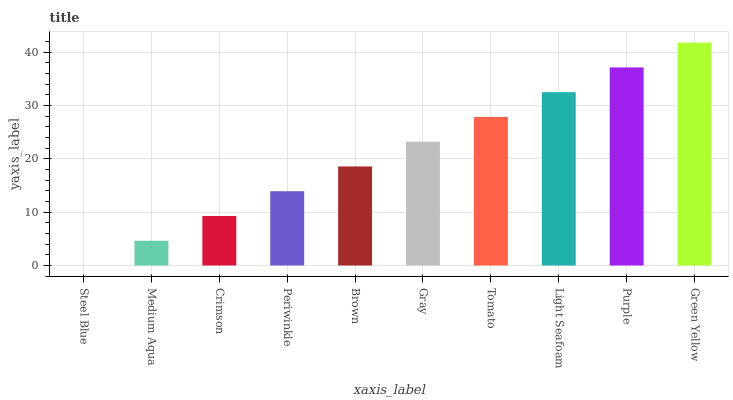Is Steel Blue the minimum?
Answer yes or no. Yes. Is Green Yellow the maximum?
Answer yes or no. Yes. Is Medium Aqua the minimum?
Answer yes or no. No. Is Medium Aqua the maximum?
Answer yes or no. No. Is Medium Aqua greater than Steel Blue?
Answer yes or no. Yes. Is Steel Blue less than Medium Aqua?
Answer yes or no. Yes. Is Steel Blue greater than Medium Aqua?
Answer yes or no. No. Is Medium Aqua less than Steel Blue?
Answer yes or no. No. Is Gray the high median?
Answer yes or no. Yes. Is Brown the low median?
Answer yes or no. Yes. Is Steel Blue the high median?
Answer yes or no. No. Is Gray the low median?
Answer yes or no. No. 